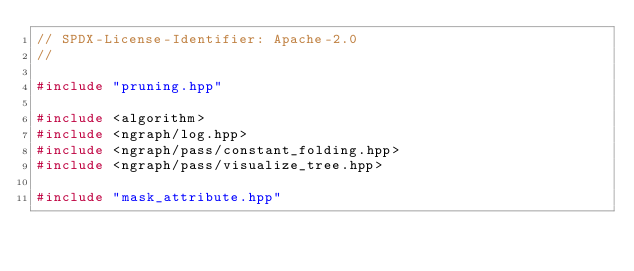Convert code to text. <code><loc_0><loc_0><loc_500><loc_500><_C++_>// SPDX-License-Identifier: Apache-2.0
//

#include "pruning.hpp"

#include <algorithm>
#include <ngraph/log.hpp>
#include <ngraph/pass/constant_folding.hpp>
#include <ngraph/pass/visualize_tree.hpp>

#include "mask_attribute.hpp"
</code> 